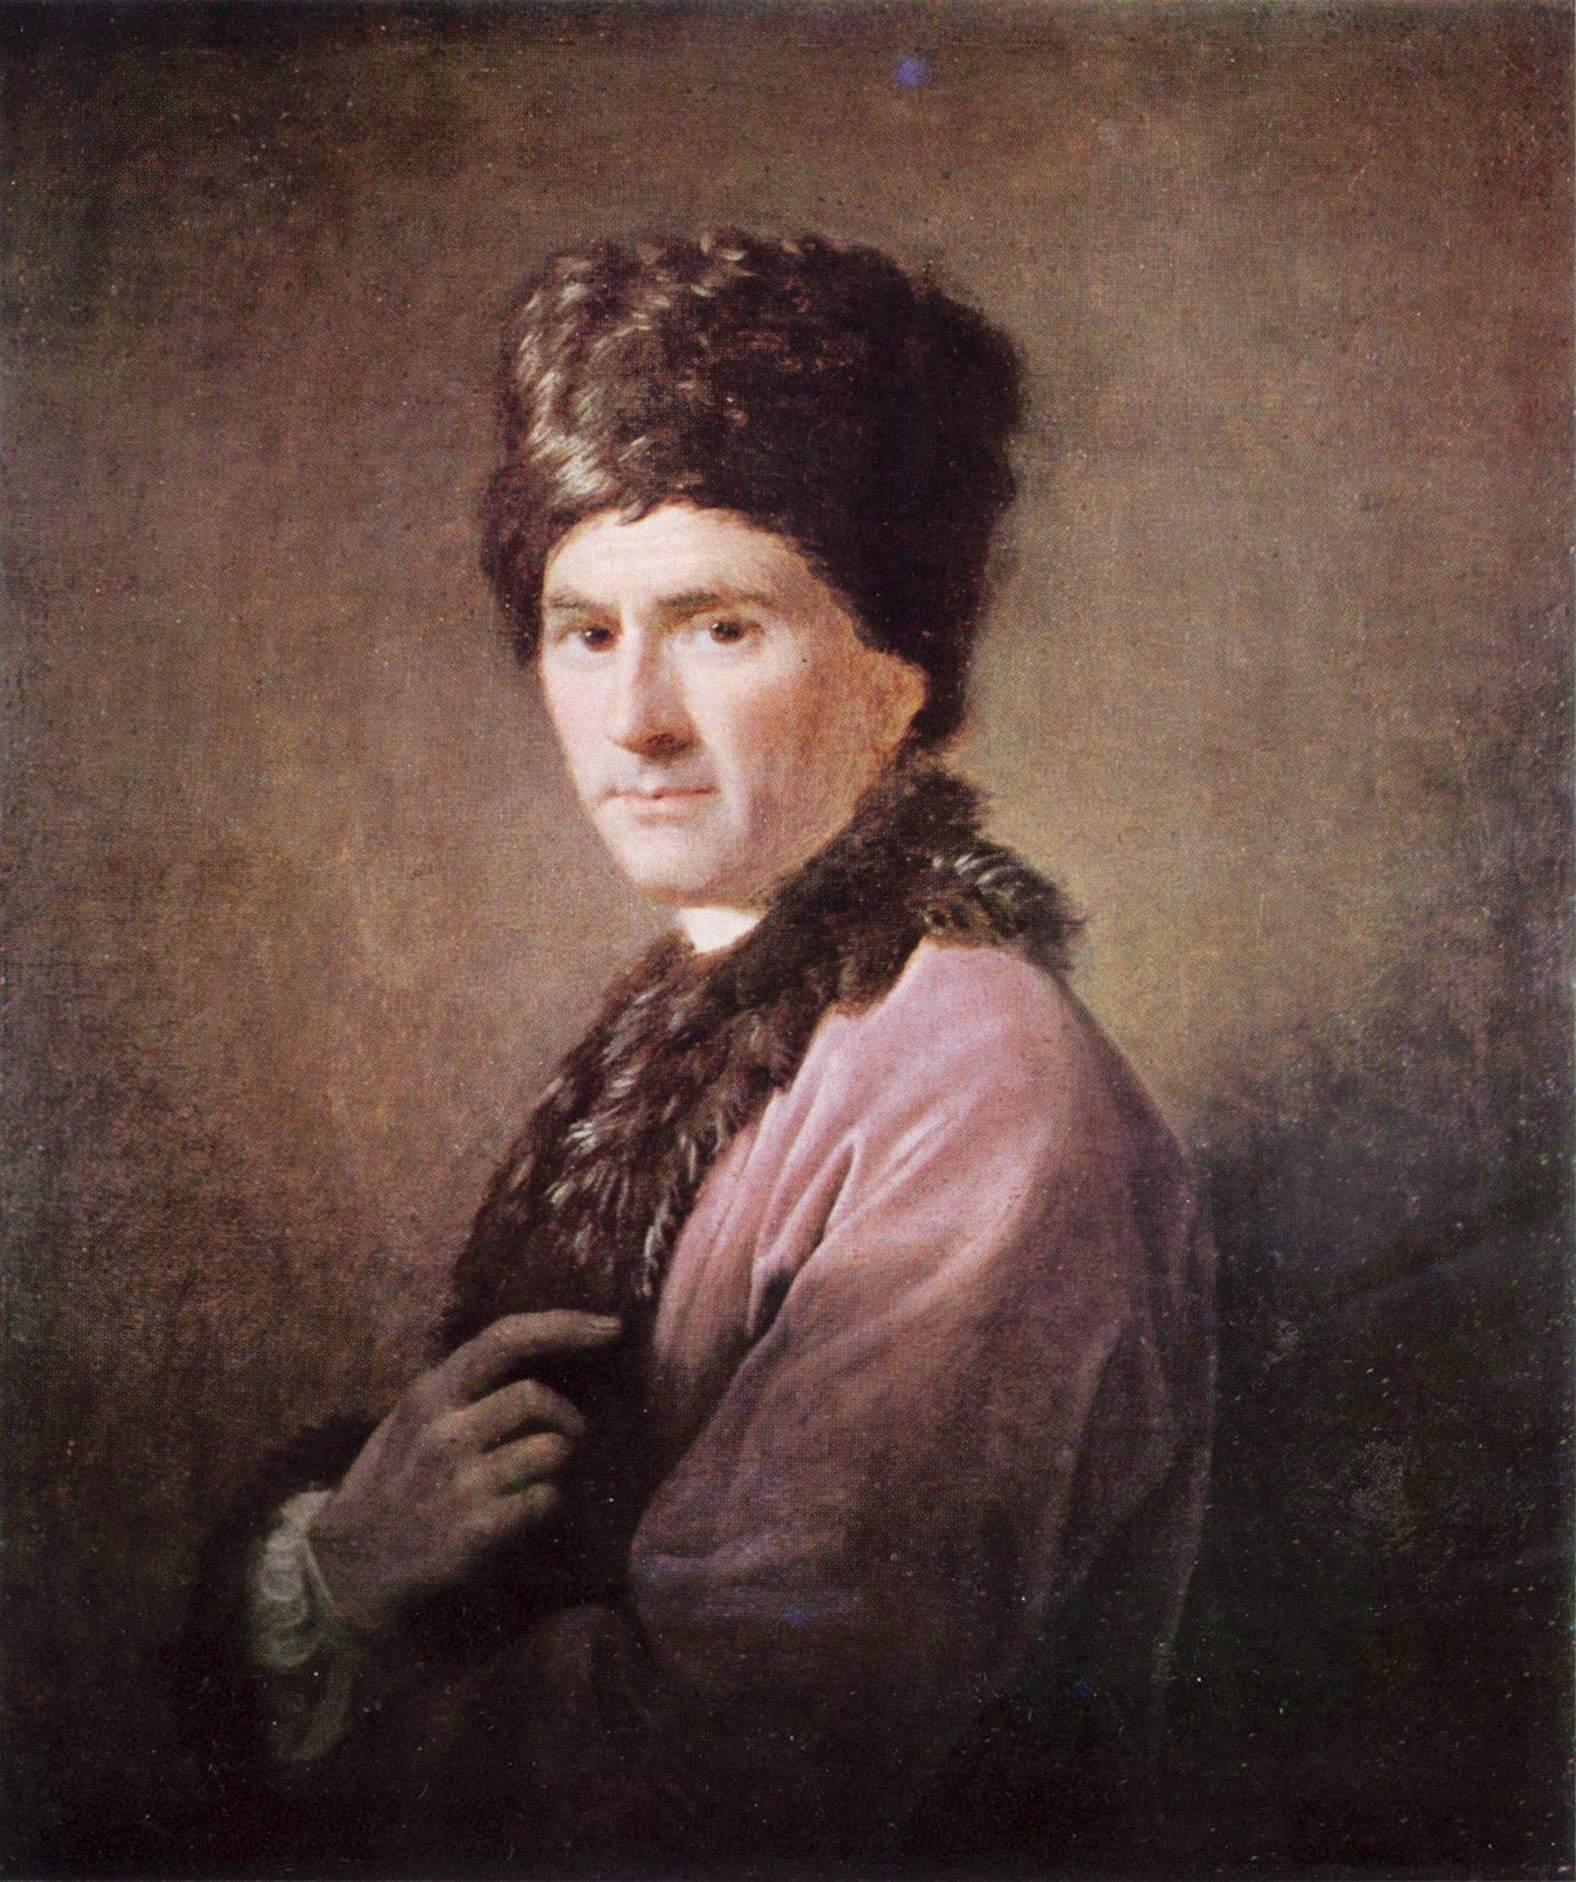Could you tell me more about the historical context of this style of clothing? The clothing seen in the painting suggests a style from a period where warmth and practicality were important considerations, possibly hinting at an Eastern European origin. The fur hat, known as a 'ushanka' or a similar traditional headwear, and the fur coat were likely worn to provide insulation against cold weather. This manner of dressing could place the subject within historical contexts ranging from the 17th to the 19th centuries, where such garments were common in colder regions. The attire denotes a certain socioeconomic status as well, where fur represented luxury and wealth. 